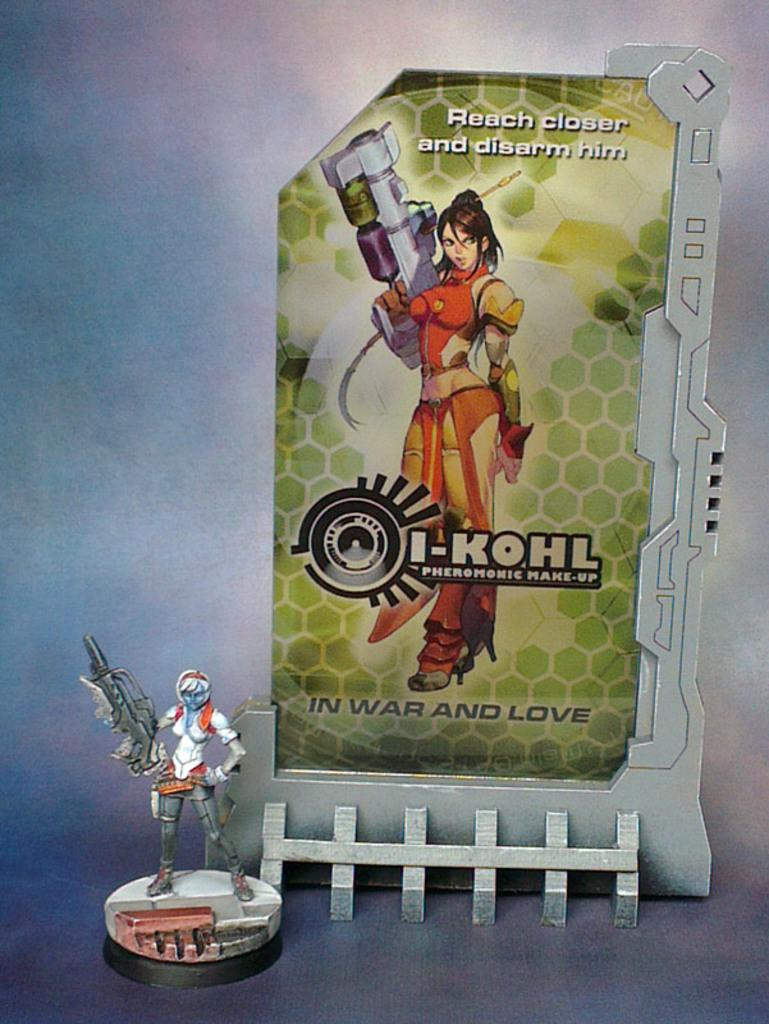<image>
Give a short and clear explanation of the subsequent image. An I-Kohl action figure out of its box. 